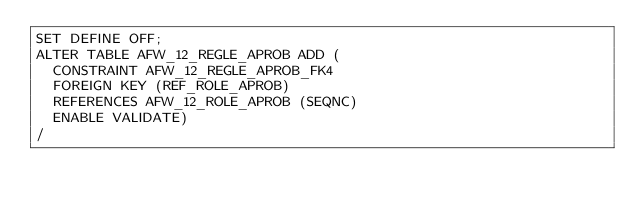Convert code to text. <code><loc_0><loc_0><loc_500><loc_500><_SQL_>SET DEFINE OFF;
ALTER TABLE AFW_12_REGLE_APROB ADD (
  CONSTRAINT AFW_12_REGLE_APROB_FK4 
  FOREIGN KEY (REF_ROLE_APROB) 
  REFERENCES AFW_12_ROLE_APROB (SEQNC)
  ENABLE VALIDATE)
/
</code> 